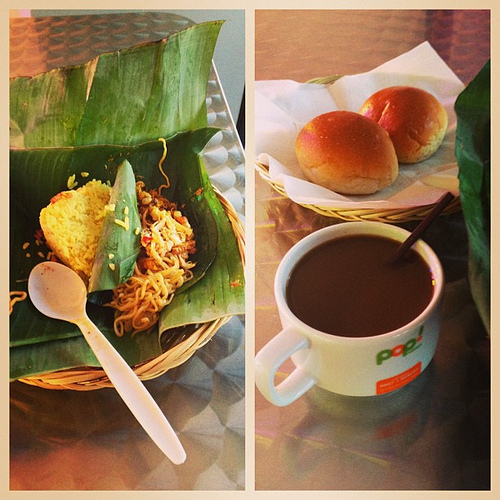What is the logo on? The eye-catching logo adorns the mug, adding a touch of branding to the simple yet elegant crockery. 